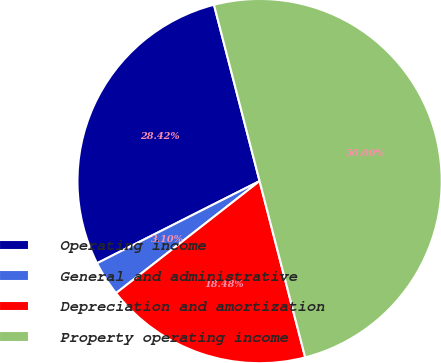Convert chart to OTSL. <chart><loc_0><loc_0><loc_500><loc_500><pie_chart><fcel>Operating income<fcel>General and administrative<fcel>Depreciation and amortization<fcel>Property operating income<nl><fcel>28.42%<fcel>3.1%<fcel>18.48%<fcel>50.0%<nl></chart> 